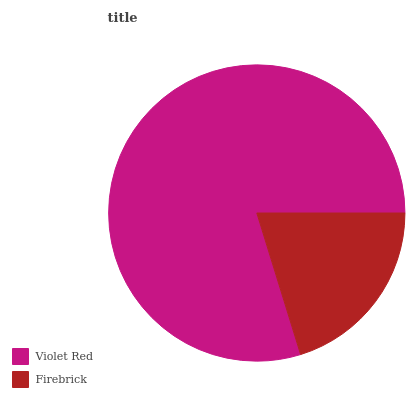Is Firebrick the minimum?
Answer yes or no. Yes. Is Violet Red the maximum?
Answer yes or no. Yes. Is Firebrick the maximum?
Answer yes or no. No. Is Violet Red greater than Firebrick?
Answer yes or no. Yes. Is Firebrick less than Violet Red?
Answer yes or no. Yes. Is Firebrick greater than Violet Red?
Answer yes or no. No. Is Violet Red less than Firebrick?
Answer yes or no. No. Is Violet Red the high median?
Answer yes or no. Yes. Is Firebrick the low median?
Answer yes or no. Yes. Is Firebrick the high median?
Answer yes or no. No. Is Violet Red the low median?
Answer yes or no. No. 